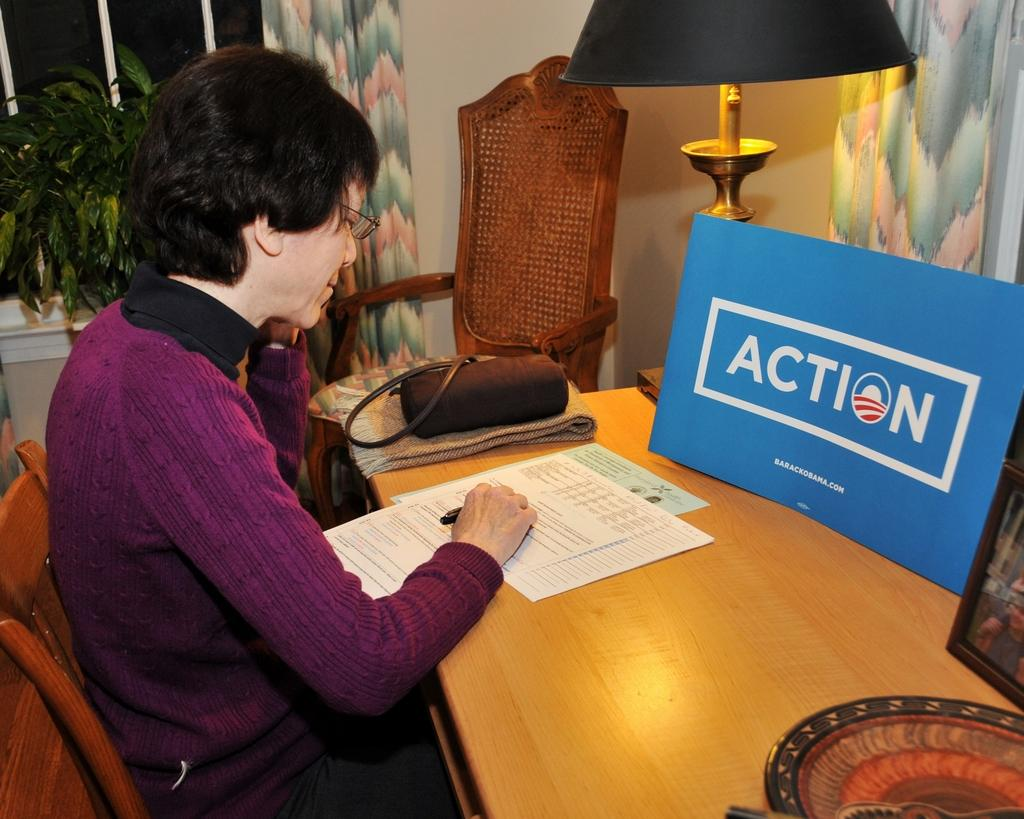Provide a one-sentence caption for the provided image. Older lady sitting at a desk with a lamp in front of a Action sign from Obama's campaign. 